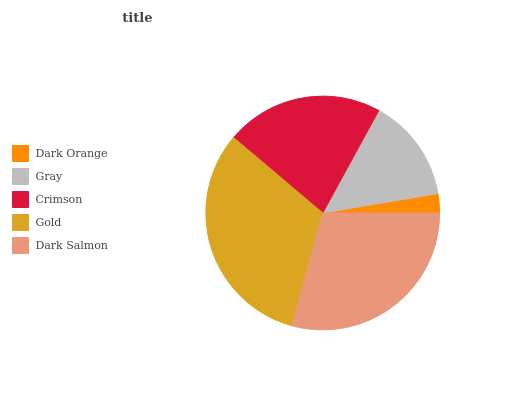Is Dark Orange the minimum?
Answer yes or no. Yes. Is Gold the maximum?
Answer yes or no. Yes. Is Gray the minimum?
Answer yes or no. No. Is Gray the maximum?
Answer yes or no. No. Is Gray greater than Dark Orange?
Answer yes or no. Yes. Is Dark Orange less than Gray?
Answer yes or no. Yes. Is Dark Orange greater than Gray?
Answer yes or no. No. Is Gray less than Dark Orange?
Answer yes or no. No. Is Crimson the high median?
Answer yes or no. Yes. Is Crimson the low median?
Answer yes or no. Yes. Is Gold the high median?
Answer yes or no. No. Is Dark Orange the low median?
Answer yes or no. No. 